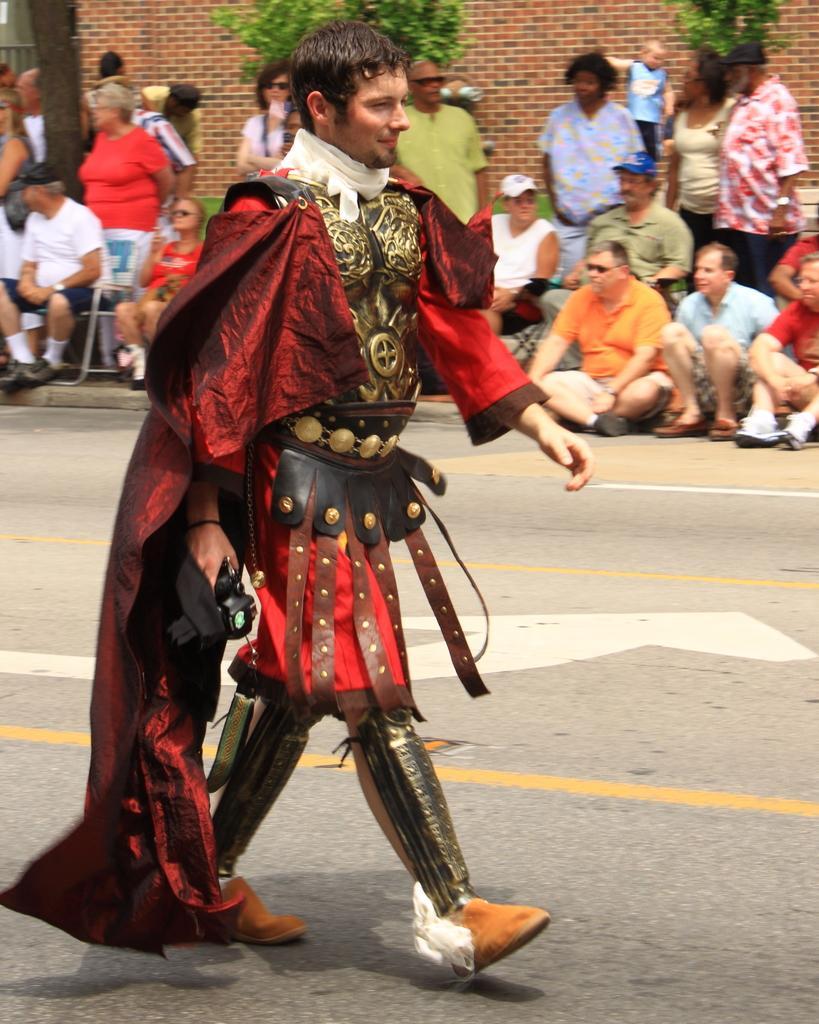How would you summarize this image in a sentence or two? In this picture we can see a man walking on the road, he is wearing a costume and in the background we can see a group of people, wall, plants and some objects. 